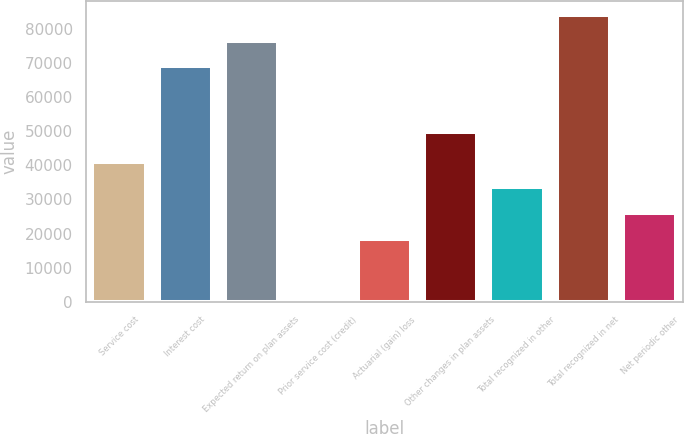Convert chart to OTSL. <chart><loc_0><loc_0><loc_500><loc_500><bar_chart><fcel>Service cost<fcel>Interest cost<fcel>Expected return on plan assets<fcel>Prior service cost (credit)<fcel>Actuarial (gain) loss<fcel>Other changes in plan assets<fcel>Total recognized in other<fcel>Total recognized in net<fcel>Net periodic other<nl><fcel>41035.4<fcel>69047<fcel>76541.8<fcel>722<fcel>18551<fcel>49852<fcel>33540.6<fcel>84036.6<fcel>26045.8<nl></chart> 